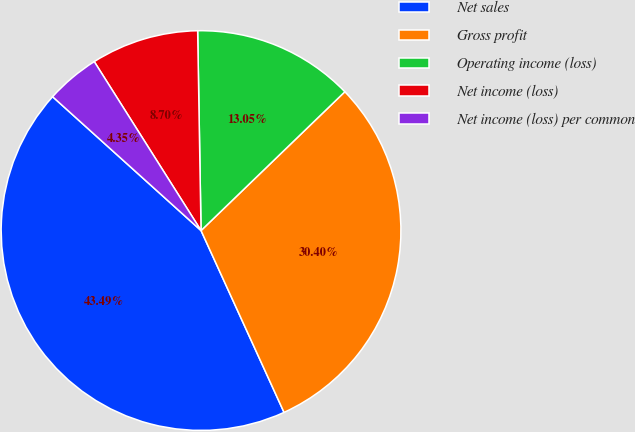Convert chart to OTSL. <chart><loc_0><loc_0><loc_500><loc_500><pie_chart><fcel>Net sales<fcel>Gross profit<fcel>Operating income (loss)<fcel>Net income (loss)<fcel>Net income (loss) per common<nl><fcel>43.49%<fcel>30.4%<fcel>13.05%<fcel>8.7%<fcel>4.35%<nl></chart> 